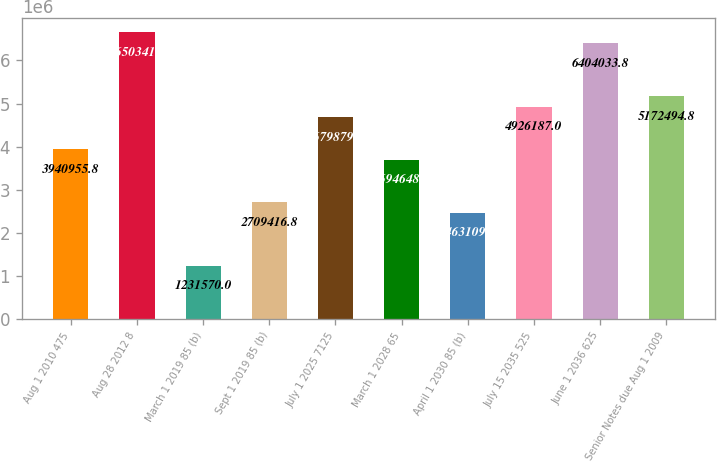Convert chart. <chart><loc_0><loc_0><loc_500><loc_500><bar_chart><fcel>Aug 1 2010 475<fcel>Aug 28 2012 8<fcel>March 1 2019 85 (b)<fcel>Sept 1 2019 85 (b)<fcel>July 1 2025 7125<fcel>March 1 2028 65<fcel>April 1 2030 85 (b)<fcel>July 15 2035 525<fcel>June 1 2036 625<fcel>Senior Notes due Aug 1 2009<nl><fcel>3.94096e+06<fcel>6.65034e+06<fcel>1.23157e+06<fcel>2.70942e+06<fcel>4.67988e+06<fcel>3.69465e+06<fcel>2.46311e+06<fcel>4.92619e+06<fcel>6.40403e+06<fcel>5.17249e+06<nl></chart> 